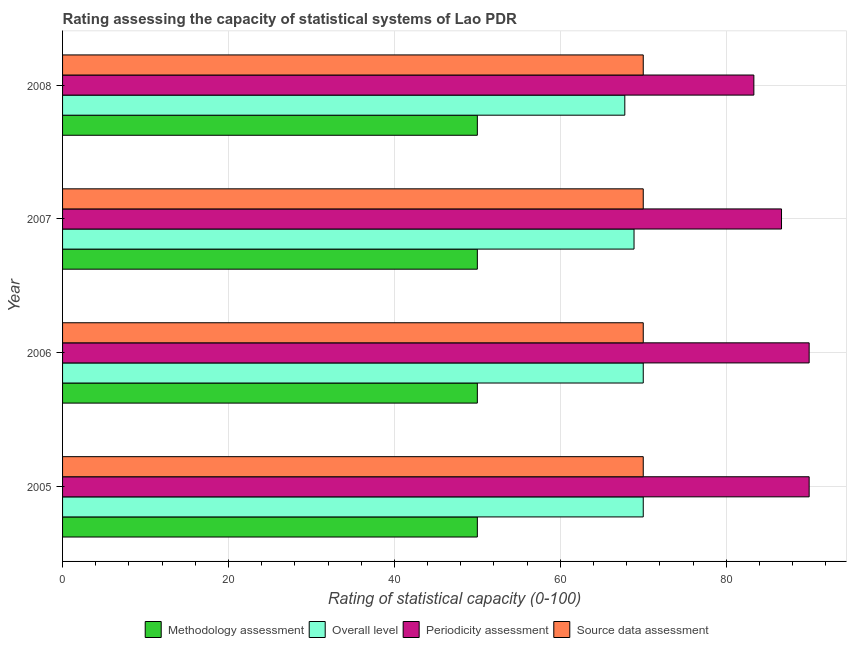How many different coloured bars are there?
Ensure brevity in your answer.  4. How many groups of bars are there?
Your response must be concise. 4. How many bars are there on the 1st tick from the top?
Your response must be concise. 4. What is the label of the 2nd group of bars from the top?
Your response must be concise. 2007. In how many cases, is the number of bars for a given year not equal to the number of legend labels?
Your response must be concise. 0. What is the source data assessment rating in 2007?
Ensure brevity in your answer.  70. Across all years, what is the maximum source data assessment rating?
Make the answer very short. 70. Across all years, what is the minimum periodicity assessment rating?
Provide a short and direct response. 83.33. In which year was the source data assessment rating minimum?
Offer a terse response. 2005. What is the total methodology assessment rating in the graph?
Your answer should be very brief. 200. What is the difference between the overall level rating in 2006 and that in 2008?
Offer a terse response. 2.22. What is the difference between the methodology assessment rating in 2005 and the periodicity assessment rating in 2008?
Ensure brevity in your answer.  -33.33. In the year 2006, what is the difference between the source data assessment rating and periodicity assessment rating?
Provide a succinct answer. -20. In how many years, is the periodicity assessment rating greater than 68 ?
Your answer should be very brief. 4. Is the methodology assessment rating in 2006 less than that in 2008?
Offer a terse response. No. Is the difference between the methodology assessment rating in 2006 and 2008 greater than the difference between the periodicity assessment rating in 2006 and 2008?
Keep it short and to the point. No. What is the difference between the highest and the second highest overall level rating?
Offer a terse response. 0. What is the difference between the highest and the lowest periodicity assessment rating?
Offer a terse response. 6.67. In how many years, is the methodology assessment rating greater than the average methodology assessment rating taken over all years?
Provide a short and direct response. 0. What does the 4th bar from the top in 2008 represents?
Make the answer very short. Methodology assessment. What does the 2nd bar from the bottom in 2007 represents?
Offer a terse response. Overall level. Are all the bars in the graph horizontal?
Provide a short and direct response. Yes. How many years are there in the graph?
Provide a short and direct response. 4. Are the values on the major ticks of X-axis written in scientific E-notation?
Your answer should be very brief. No. Where does the legend appear in the graph?
Ensure brevity in your answer.  Bottom center. How are the legend labels stacked?
Make the answer very short. Horizontal. What is the title of the graph?
Provide a short and direct response. Rating assessing the capacity of statistical systems of Lao PDR. What is the label or title of the X-axis?
Offer a very short reply. Rating of statistical capacity (0-100). What is the Rating of statistical capacity (0-100) of Overall level in 2005?
Offer a terse response. 70. What is the Rating of statistical capacity (0-100) of Periodicity assessment in 2005?
Offer a very short reply. 90. What is the Rating of statistical capacity (0-100) in Overall level in 2006?
Provide a short and direct response. 70. What is the Rating of statistical capacity (0-100) of Periodicity assessment in 2006?
Offer a terse response. 90. What is the Rating of statistical capacity (0-100) in Methodology assessment in 2007?
Offer a terse response. 50. What is the Rating of statistical capacity (0-100) in Overall level in 2007?
Offer a very short reply. 68.89. What is the Rating of statistical capacity (0-100) in Periodicity assessment in 2007?
Keep it short and to the point. 86.67. What is the Rating of statistical capacity (0-100) in Methodology assessment in 2008?
Offer a very short reply. 50. What is the Rating of statistical capacity (0-100) in Overall level in 2008?
Offer a very short reply. 67.78. What is the Rating of statistical capacity (0-100) of Periodicity assessment in 2008?
Your answer should be compact. 83.33. Across all years, what is the maximum Rating of statistical capacity (0-100) in Overall level?
Make the answer very short. 70. Across all years, what is the maximum Rating of statistical capacity (0-100) in Periodicity assessment?
Keep it short and to the point. 90. Across all years, what is the minimum Rating of statistical capacity (0-100) of Methodology assessment?
Offer a very short reply. 50. Across all years, what is the minimum Rating of statistical capacity (0-100) in Overall level?
Keep it short and to the point. 67.78. Across all years, what is the minimum Rating of statistical capacity (0-100) of Periodicity assessment?
Keep it short and to the point. 83.33. What is the total Rating of statistical capacity (0-100) of Overall level in the graph?
Offer a terse response. 276.67. What is the total Rating of statistical capacity (0-100) of Periodicity assessment in the graph?
Offer a terse response. 350. What is the total Rating of statistical capacity (0-100) in Source data assessment in the graph?
Offer a very short reply. 280. What is the difference between the Rating of statistical capacity (0-100) of Overall level in 2005 and that in 2006?
Keep it short and to the point. 0. What is the difference between the Rating of statistical capacity (0-100) of Source data assessment in 2005 and that in 2006?
Provide a succinct answer. 0. What is the difference between the Rating of statistical capacity (0-100) in Methodology assessment in 2005 and that in 2007?
Your answer should be very brief. 0. What is the difference between the Rating of statistical capacity (0-100) of Periodicity assessment in 2005 and that in 2007?
Your response must be concise. 3.33. What is the difference between the Rating of statistical capacity (0-100) in Methodology assessment in 2005 and that in 2008?
Give a very brief answer. 0. What is the difference between the Rating of statistical capacity (0-100) in Overall level in 2005 and that in 2008?
Offer a very short reply. 2.22. What is the difference between the Rating of statistical capacity (0-100) of Periodicity assessment in 2005 and that in 2008?
Give a very brief answer. 6.67. What is the difference between the Rating of statistical capacity (0-100) of Source data assessment in 2005 and that in 2008?
Your answer should be compact. 0. What is the difference between the Rating of statistical capacity (0-100) in Methodology assessment in 2006 and that in 2007?
Ensure brevity in your answer.  0. What is the difference between the Rating of statistical capacity (0-100) in Overall level in 2006 and that in 2007?
Your answer should be compact. 1.11. What is the difference between the Rating of statistical capacity (0-100) in Periodicity assessment in 2006 and that in 2007?
Your response must be concise. 3.33. What is the difference between the Rating of statistical capacity (0-100) in Methodology assessment in 2006 and that in 2008?
Ensure brevity in your answer.  0. What is the difference between the Rating of statistical capacity (0-100) of Overall level in 2006 and that in 2008?
Provide a succinct answer. 2.22. What is the difference between the Rating of statistical capacity (0-100) of Periodicity assessment in 2007 and that in 2008?
Your response must be concise. 3.33. What is the difference between the Rating of statistical capacity (0-100) in Methodology assessment in 2005 and the Rating of statistical capacity (0-100) in Overall level in 2006?
Provide a succinct answer. -20. What is the difference between the Rating of statistical capacity (0-100) in Methodology assessment in 2005 and the Rating of statistical capacity (0-100) in Source data assessment in 2006?
Offer a terse response. -20. What is the difference between the Rating of statistical capacity (0-100) of Methodology assessment in 2005 and the Rating of statistical capacity (0-100) of Overall level in 2007?
Provide a short and direct response. -18.89. What is the difference between the Rating of statistical capacity (0-100) in Methodology assessment in 2005 and the Rating of statistical capacity (0-100) in Periodicity assessment in 2007?
Your answer should be compact. -36.67. What is the difference between the Rating of statistical capacity (0-100) of Methodology assessment in 2005 and the Rating of statistical capacity (0-100) of Source data assessment in 2007?
Your response must be concise. -20. What is the difference between the Rating of statistical capacity (0-100) of Overall level in 2005 and the Rating of statistical capacity (0-100) of Periodicity assessment in 2007?
Make the answer very short. -16.67. What is the difference between the Rating of statistical capacity (0-100) in Methodology assessment in 2005 and the Rating of statistical capacity (0-100) in Overall level in 2008?
Offer a very short reply. -17.78. What is the difference between the Rating of statistical capacity (0-100) of Methodology assessment in 2005 and the Rating of statistical capacity (0-100) of Periodicity assessment in 2008?
Your response must be concise. -33.33. What is the difference between the Rating of statistical capacity (0-100) of Overall level in 2005 and the Rating of statistical capacity (0-100) of Periodicity assessment in 2008?
Keep it short and to the point. -13.33. What is the difference between the Rating of statistical capacity (0-100) in Overall level in 2005 and the Rating of statistical capacity (0-100) in Source data assessment in 2008?
Provide a succinct answer. 0. What is the difference between the Rating of statistical capacity (0-100) of Methodology assessment in 2006 and the Rating of statistical capacity (0-100) of Overall level in 2007?
Your answer should be very brief. -18.89. What is the difference between the Rating of statistical capacity (0-100) of Methodology assessment in 2006 and the Rating of statistical capacity (0-100) of Periodicity assessment in 2007?
Offer a very short reply. -36.67. What is the difference between the Rating of statistical capacity (0-100) of Methodology assessment in 2006 and the Rating of statistical capacity (0-100) of Source data assessment in 2007?
Provide a succinct answer. -20. What is the difference between the Rating of statistical capacity (0-100) in Overall level in 2006 and the Rating of statistical capacity (0-100) in Periodicity assessment in 2007?
Offer a very short reply. -16.67. What is the difference between the Rating of statistical capacity (0-100) of Periodicity assessment in 2006 and the Rating of statistical capacity (0-100) of Source data assessment in 2007?
Your response must be concise. 20. What is the difference between the Rating of statistical capacity (0-100) in Methodology assessment in 2006 and the Rating of statistical capacity (0-100) in Overall level in 2008?
Provide a succinct answer. -17.78. What is the difference between the Rating of statistical capacity (0-100) in Methodology assessment in 2006 and the Rating of statistical capacity (0-100) in Periodicity assessment in 2008?
Offer a very short reply. -33.33. What is the difference between the Rating of statistical capacity (0-100) of Methodology assessment in 2006 and the Rating of statistical capacity (0-100) of Source data assessment in 2008?
Your answer should be compact. -20. What is the difference between the Rating of statistical capacity (0-100) in Overall level in 2006 and the Rating of statistical capacity (0-100) in Periodicity assessment in 2008?
Offer a very short reply. -13.33. What is the difference between the Rating of statistical capacity (0-100) of Overall level in 2006 and the Rating of statistical capacity (0-100) of Source data assessment in 2008?
Keep it short and to the point. 0. What is the difference between the Rating of statistical capacity (0-100) of Methodology assessment in 2007 and the Rating of statistical capacity (0-100) of Overall level in 2008?
Ensure brevity in your answer.  -17.78. What is the difference between the Rating of statistical capacity (0-100) of Methodology assessment in 2007 and the Rating of statistical capacity (0-100) of Periodicity assessment in 2008?
Keep it short and to the point. -33.33. What is the difference between the Rating of statistical capacity (0-100) of Overall level in 2007 and the Rating of statistical capacity (0-100) of Periodicity assessment in 2008?
Offer a terse response. -14.44. What is the difference between the Rating of statistical capacity (0-100) of Overall level in 2007 and the Rating of statistical capacity (0-100) of Source data assessment in 2008?
Your answer should be compact. -1.11. What is the difference between the Rating of statistical capacity (0-100) in Periodicity assessment in 2007 and the Rating of statistical capacity (0-100) in Source data assessment in 2008?
Your answer should be compact. 16.67. What is the average Rating of statistical capacity (0-100) of Methodology assessment per year?
Give a very brief answer. 50. What is the average Rating of statistical capacity (0-100) in Overall level per year?
Your answer should be very brief. 69.17. What is the average Rating of statistical capacity (0-100) of Periodicity assessment per year?
Provide a short and direct response. 87.5. In the year 2005, what is the difference between the Rating of statistical capacity (0-100) in Methodology assessment and Rating of statistical capacity (0-100) in Periodicity assessment?
Your response must be concise. -40. In the year 2005, what is the difference between the Rating of statistical capacity (0-100) of Methodology assessment and Rating of statistical capacity (0-100) of Source data assessment?
Your answer should be compact. -20. In the year 2005, what is the difference between the Rating of statistical capacity (0-100) in Overall level and Rating of statistical capacity (0-100) in Periodicity assessment?
Make the answer very short. -20. In the year 2005, what is the difference between the Rating of statistical capacity (0-100) of Overall level and Rating of statistical capacity (0-100) of Source data assessment?
Keep it short and to the point. 0. In the year 2006, what is the difference between the Rating of statistical capacity (0-100) of Methodology assessment and Rating of statistical capacity (0-100) of Overall level?
Provide a short and direct response. -20. In the year 2006, what is the difference between the Rating of statistical capacity (0-100) of Methodology assessment and Rating of statistical capacity (0-100) of Periodicity assessment?
Your answer should be very brief. -40. In the year 2006, what is the difference between the Rating of statistical capacity (0-100) of Overall level and Rating of statistical capacity (0-100) of Periodicity assessment?
Your answer should be very brief. -20. In the year 2006, what is the difference between the Rating of statistical capacity (0-100) in Overall level and Rating of statistical capacity (0-100) in Source data assessment?
Your response must be concise. 0. In the year 2006, what is the difference between the Rating of statistical capacity (0-100) of Periodicity assessment and Rating of statistical capacity (0-100) of Source data assessment?
Your response must be concise. 20. In the year 2007, what is the difference between the Rating of statistical capacity (0-100) of Methodology assessment and Rating of statistical capacity (0-100) of Overall level?
Keep it short and to the point. -18.89. In the year 2007, what is the difference between the Rating of statistical capacity (0-100) of Methodology assessment and Rating of statistical capacity (0-100) of Periodicity assessment?
Your answer should be compact. -36.67. In the year 2007, what is the difference between the Rating of statistical capacity (0-100) in Methodology assessment and Rating of statistical capacity (0-100) in Source data assessment?
Keep it short and to the point. -20. In the year 2007, what is the difference between the Rating of statistical capacity (0-100) of Overall level and Rating of statistical capacity (0-100) of Periodicity assessment?
Offer a terse response. -17.78. In the year 2007, what is the difference between the Rating of statistical capacity (0-100) in Overall level and Rating of statistical capacity (0-100) in Source data assessment?
Make the answer very short. -1.11. In the year 2007, what is the difference between the Rating of statistical capacity (0-100) in Periodicity assessment and Rating of statistical capacity (0-100) in Source data assessment?
Make the answer very short. 16.67. In the year 2008, what is the difference between the Rating of statistical capacity (0-100) in Methodology assessment and Rating of statistical capacity (0-100) in Overall level?
Offer a terse response. -17.78. In the year 2008, what is the difference between the Rating of statistical capacity (0-100) in Methodology assessment and Rating of statistical capacity (0-100) in Periodicity assessment?
Your answer should be compact. -33.33. In the year 2008, what is the difference between the Rating of statistical capacity (0-100) of Overall level and Rating of statistical capacity (0-100) of Periodicity assessment?
Offer a terse response. -15.56. In the year 2008, what is the difference between the Rating of statistical capacity (0-100) of Overall level and Rating of statistical capacity (0-100) of Source data assessment?
Provide a succinct answer. -2.22. In the year 2008, what is the difference between the Rating of statistical capacity (0-100) of Periodicity assessment and Rating of statistical capacity (0-100) of Source data assessment?
Keep it short and to the point. 13.33. What is the ratio of the Rating of statistical capacity (0-100) in Methodology assessment in 2005 to that in 2006?
Give a very brief answer. 1. What is the ratio of the Rating of statistical capacity (0-100) of Periodicity assessment in 2005 to that in 2006?
Offer a very short reply. 1. What is the ratio of the Rating of statistical capacity (0-100) of Methodology assessment in 2005 to that in 2007?
Your answer should be very brief. 1. What is the ratio of the Rating of statistical capacity (0-100) of Overall level in 2005 to that in 2007?
Your response must be concise. 1.02. What is the ratio of the Rating of statistical capacity (0-100) of Source data assessment in 2005 to that in 2007?
Give a very brief answer. 1. What is the ratio of the Rating of statistical capacity (0-100) in Overall level in 2005 to that in 2008?
Ensure brevity in your answer.  1.03. What is the ratio of the Rating of statistical capacity (0-100) of Periodicity assessment in 2005 to that in 2008?
Provide a succinct answer. 1.08. What is the ratio of the Rating of statistical capacity (0-100) of Methodology assessment in 2006 to that in 2007?
Your response must be concise. 1. What is the ratio of the Rating of statistical capacity (0-100) of Overall level in 2006 to that in 2007?
Your answer should be very brief. 1.02. What is the ratio of the Rating of statistical capacity (0-100) of Methodology assessment in 2006 to that in 2008?
Make the answer very short. 1. What is the ratio of the Rating of statistical capacity (0-100) in Overall level in 2006 to that in 2008?
Offer a terse response. 1.03. What is the ratio of the Rating of statistical capacity (0-100) of Source data assessment in 2006 to that in 2008?
Offer a terse response. 1. What is the ratio of the Rating of statistical capacity (0-100) of Methodology assessment in 2007 to that in 2008?
Provide a succinct answer. 1. What is the ratio of the Rating of statistical capacity (0-100) in Overall level in 2007 to that in 2008?
Provide a short and direct response. 1.02. What is the ratio of the Rating of statistical capacity (0-100) of Periodicity assessment in 2007 to that in 2008?
Your response must be concise. 1.04. What is the ratio of the Rating of statistical capacity (0-100) of Source data assessment in 2007 to that in 2008?
Give a very brief answer. 1. What is the difference between the highest and the second highest Rating of statistical capacity (0-100) in Periodicity assessment?
Ensure brevity in your answer.  0. What is the difference between the highest and the second highest Rating of statistical capacity (0-100) of Source data assessment?
Your answer should be compact. 0. What is the difference between the highest and the lowest Rating of statistical capacity (0-100) of Methodology assessment?
Your answer should be compact. 0. What is the difference between the highest and the lowest Rating of statistical capacity (0-100) in Overall level?
Ensure brevity in your answer.  2.22. What is the difference between the highest and the lowest Rating of statistical capacity (0-100) in Source data assessment?
Ensure brevity in your answer.  0. 